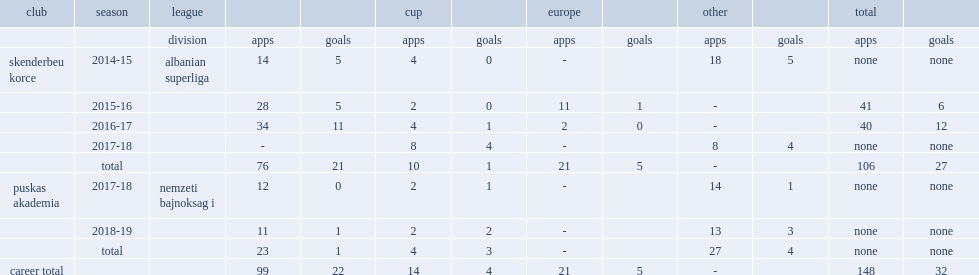I'm looking to parse the entire table for insights. Could you assist me with that? {'header': ['club', 'season', 'league', '', '', 'cup', '', 'europe', '', 'other', '', 'total', ''], 'rows': [['', '', 'division', 'apps', 'goals', 'apps', 'goals', 'apps', 'goals', 'apps', 'goals', 'apps', 'goals'], ['skenderbeu korce', '2014-15', 'albanian superliga', '14', '5', '4', '0', '-', '', '18', '5', 'none', 'none'], ['', '2015-16', '', '28', '5', '2', '0', '11', '1', '-', '', '41', '6'], ['', '2016-17', '', '34', '11', '4', '1', '2', '0', '-', '', '40', '12'], ['', '2017-18', '', '-', '', '8', '4', '-', '', '8', '4', 'none', 'none'], ['', 'total', '', '76', '21', '10', '1', '21', '5', '-', '', '106', '27'], ['puskas akademia', '2017-18', 'nemzeti bajnoksag i', '12', '0', '2', '1', '-', '', '14', '1', 'none', 'none'], ['', '2018-19', '', '11', '1', '2', '2', '-', '', '13', '3', 'none', 'none'], ['', 'total', '', '23', '1', '4', '3', '-', '', '27', '4', 'none', 'none'], ['career total', '', '', '99', '22', '14', '4', '21', '5', '-', '', '148', '32']]} In 2014, which club did latifi join in albanian superliga? Skenderbeu korce. 